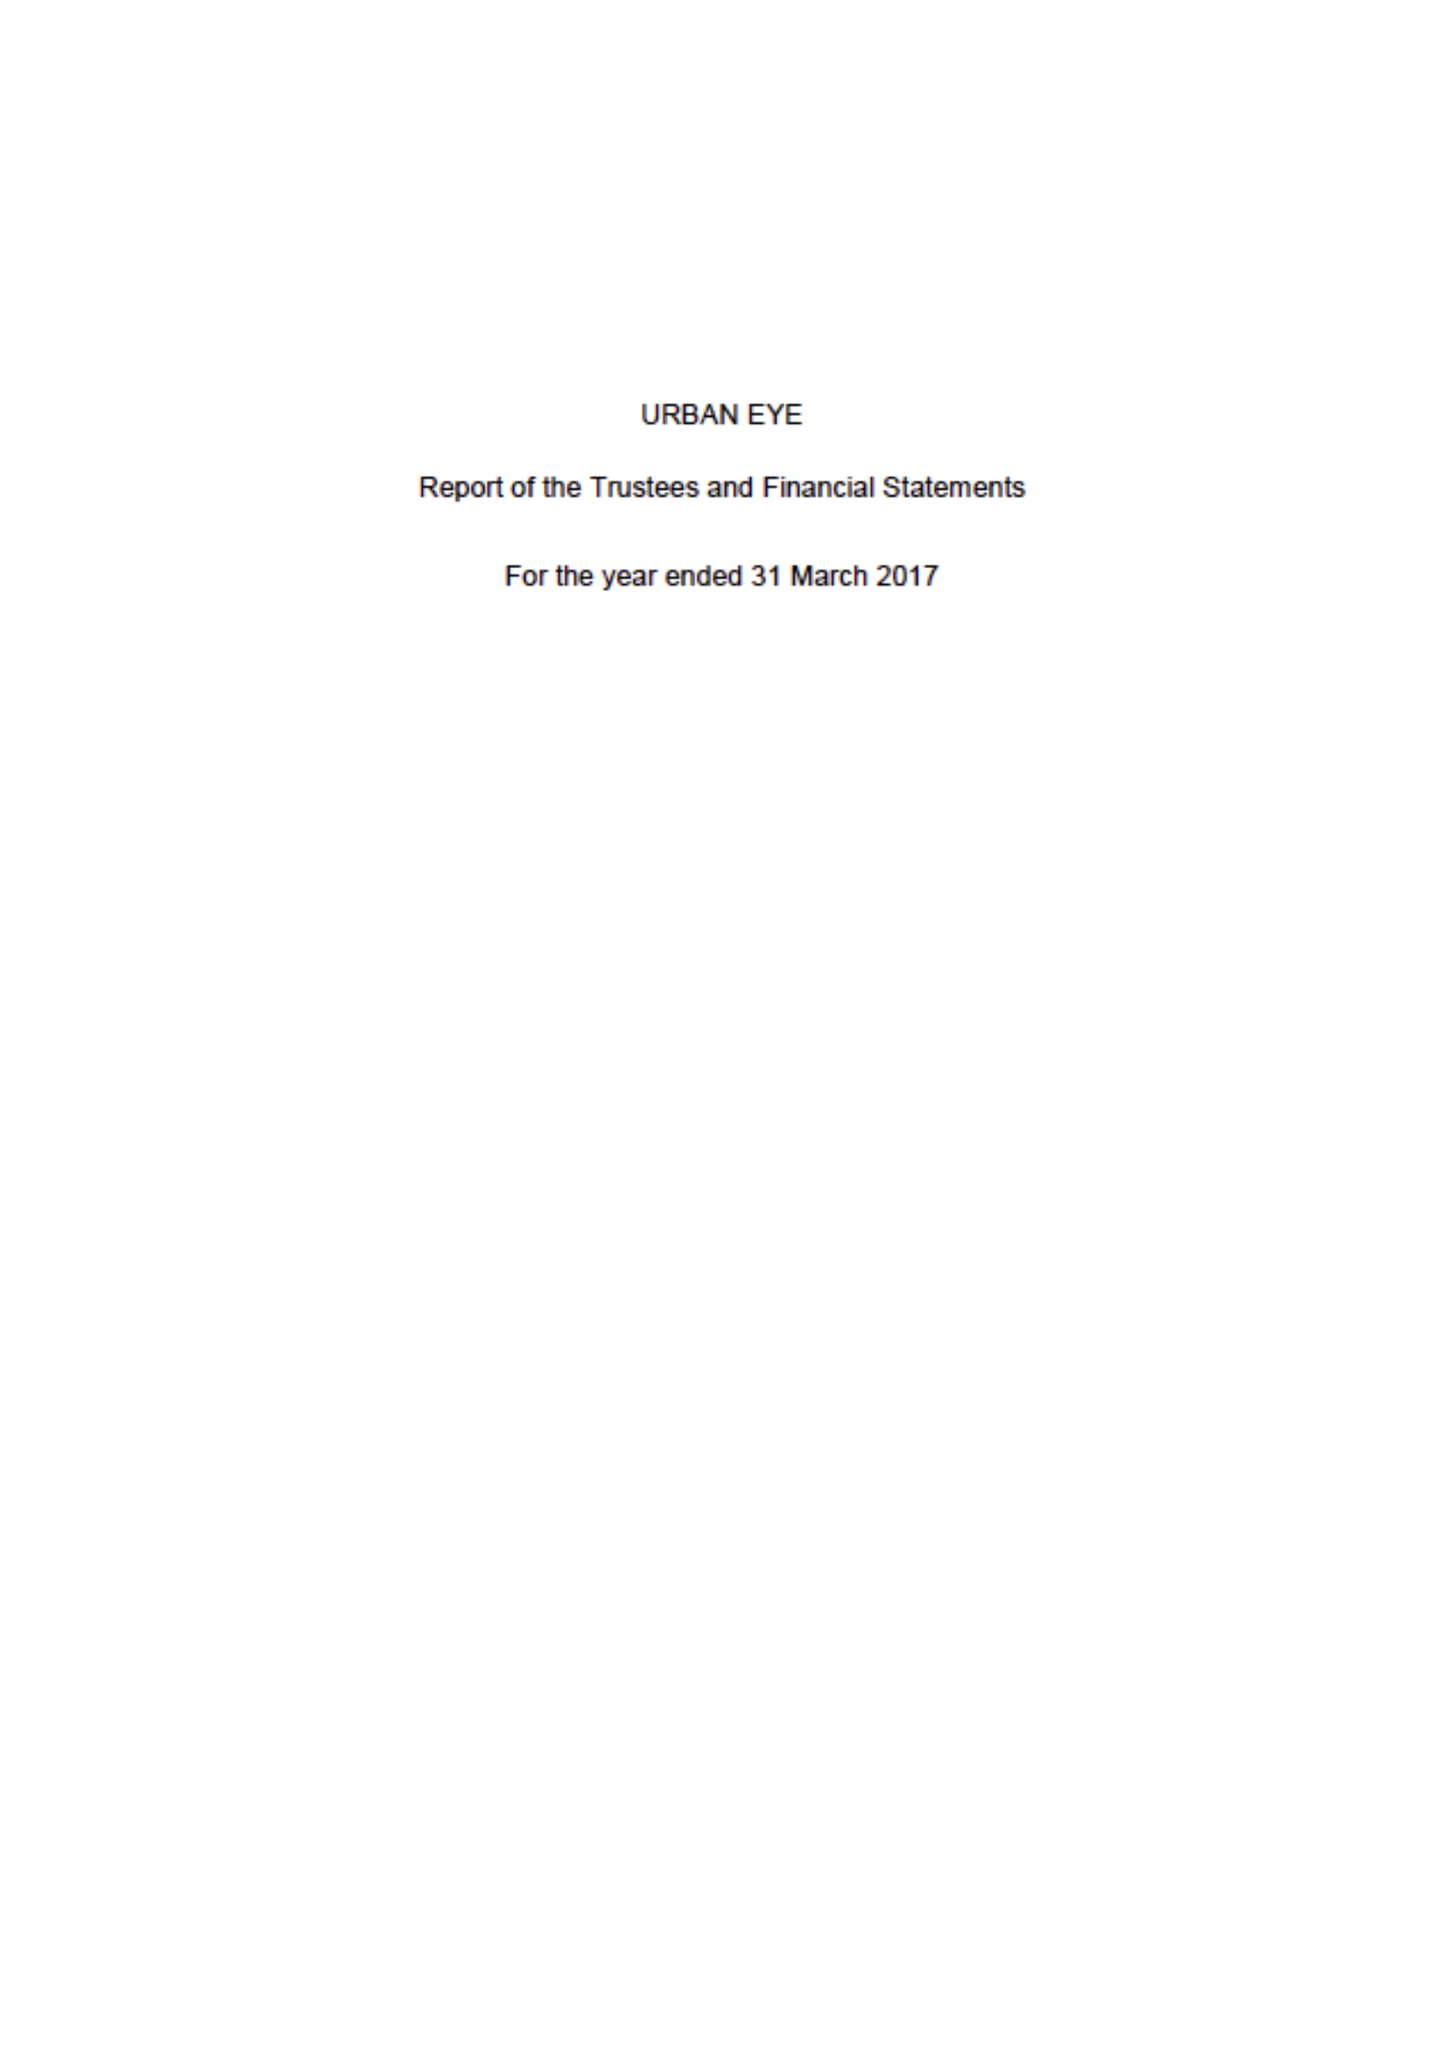What is the value for the spending_annually_in_british_pounds?
Answer the question using a single word or phrase. 58531.00 